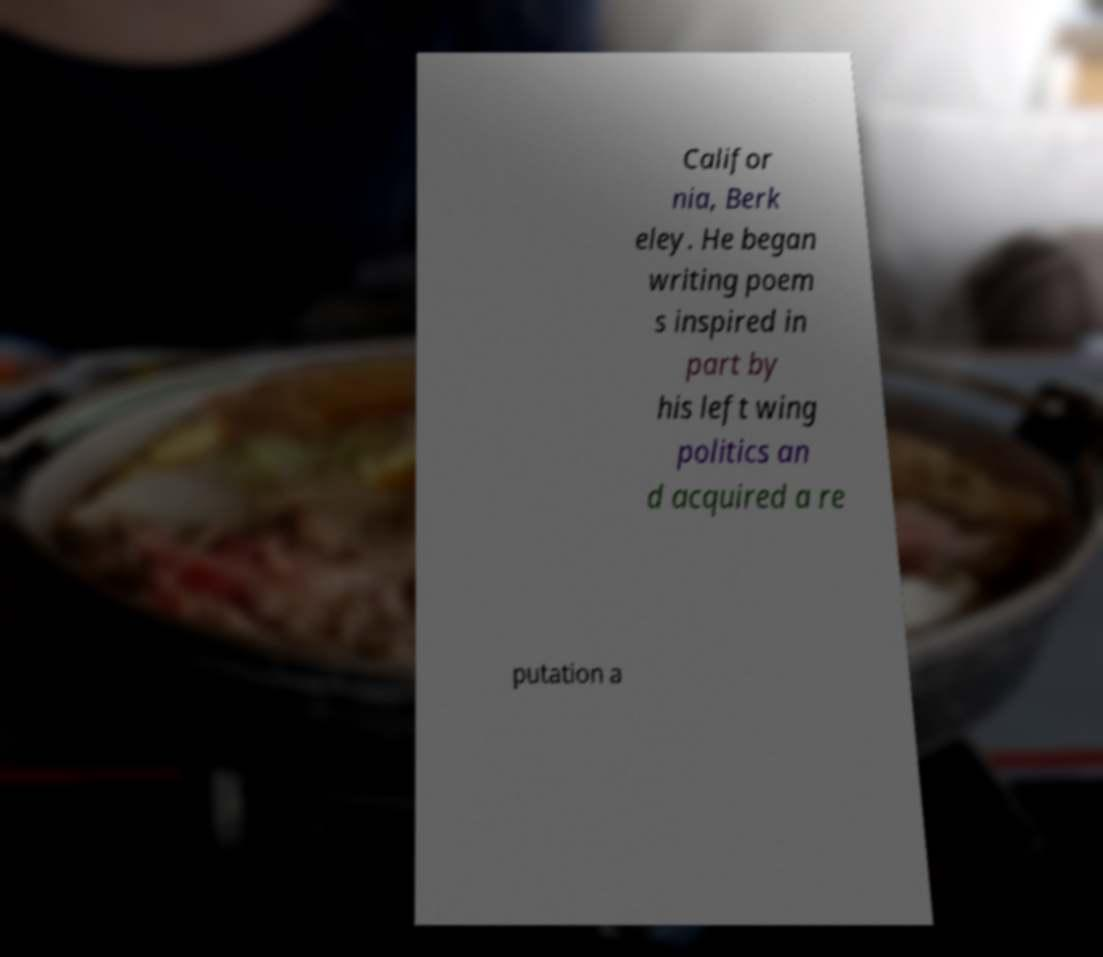There's text embedded in this image that I need extracted. Can you transcribe it verbatim? Califor nia, Berk eley. He began writing poem s inspired in part by his left wing politics an d acquired a re putation a 